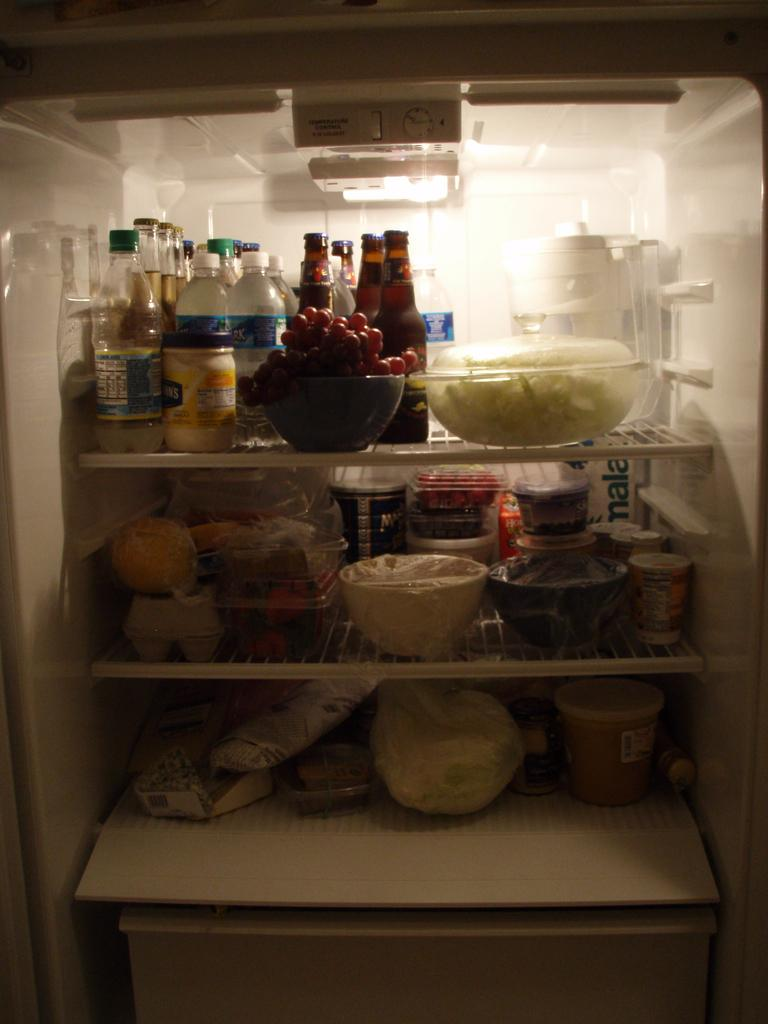<image>
Describe the image concisely. An image of an open fridge which is packed with food, the clearest item being a jar of Hellmans Mayo. 